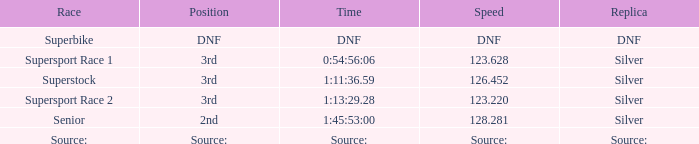Which race has a position of 3rd and a speed of 123.628? Supersport Race 1. 